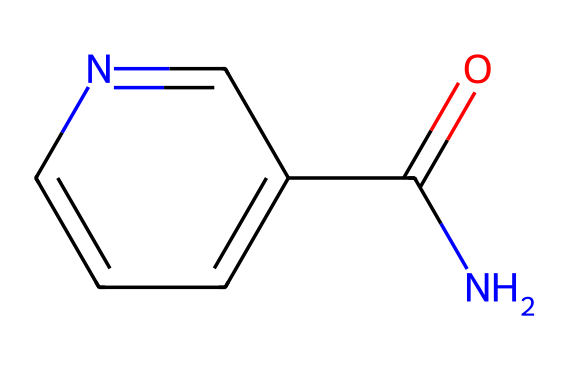What is the molecular formula of this chemical? To determine the molecular formula, we count the number of each type of atom present in the structure. This chemical contains 6 carbon (C) atoms, 8 hydrogen (H) atoms, 1 nitrogen (N) atom, and 1 oxygen (O) atom, leading to the molecular formula C6H6N2O.
Answer: C6H6N2O How many rings are present in this chemical structure? By examining the structure, we can identify that there is one aromatic ring (the pyridine ring) as part of the composition. The absence of any other cyclic structures indicates that there is only one ring in this chemical.
Answer: 1 What functional groups are present in this chemical? This chemical features a carboxamide group (indicated by the NC(=O) moiety) and an aromatic amine (which can be inferred from the nitrogen in the ring structure). Therefore, the identified functional groups are a carboxamide and an amine.
Answer: carboxamide, amine What is the primary biological role of niacinamide in skincare? Niacinamide is primarily known for its role in skin brightening and anti-aging due to its ability to improve skin barrier function, enhance hydration, and reduce hyperpigmentation, making it effective for post-competition skincare.
Answer: skin brightening, anti-aging How does the nitrogen atom affect the chemical's properties? The nitrogen atom in niacinamide contributes to its hydrophilicity and enhances its ability to form hydrogen bonds with other molecules, which is critical for its solubility in water and interaction with skin cells.
Answer: hydrophilicity What type of chemical is niacinamide primarily classified as? Niacinamide falls under the category of vitamin derivatives, specifically a form of vitamin B3, and is widely used in cosmetic formulations due to its beneficial skin properties.
Answer: vitamin derivative 